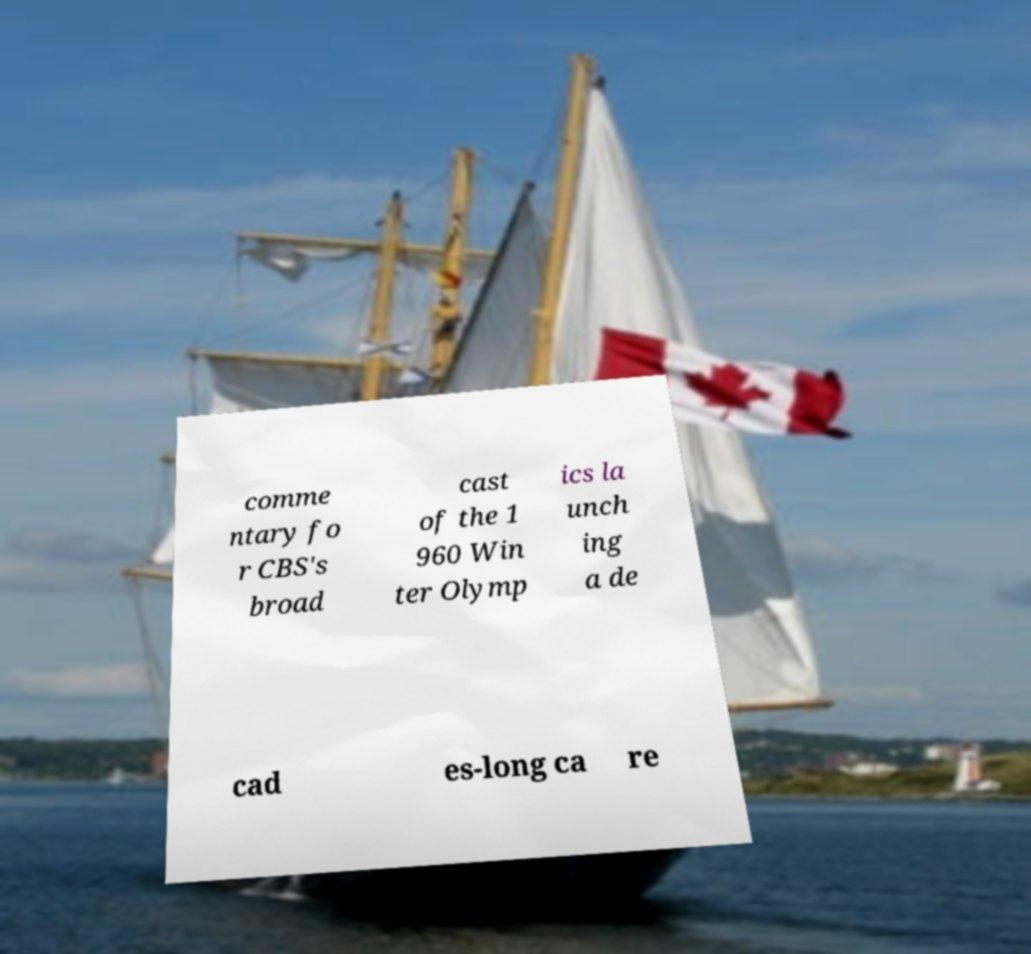Please read and relay the text visible in this image. What does it say? comme ntary fo r CBS's broad cast of the 1 960 Win ter Olymp ics la unch ing a de cad es-long ca re 